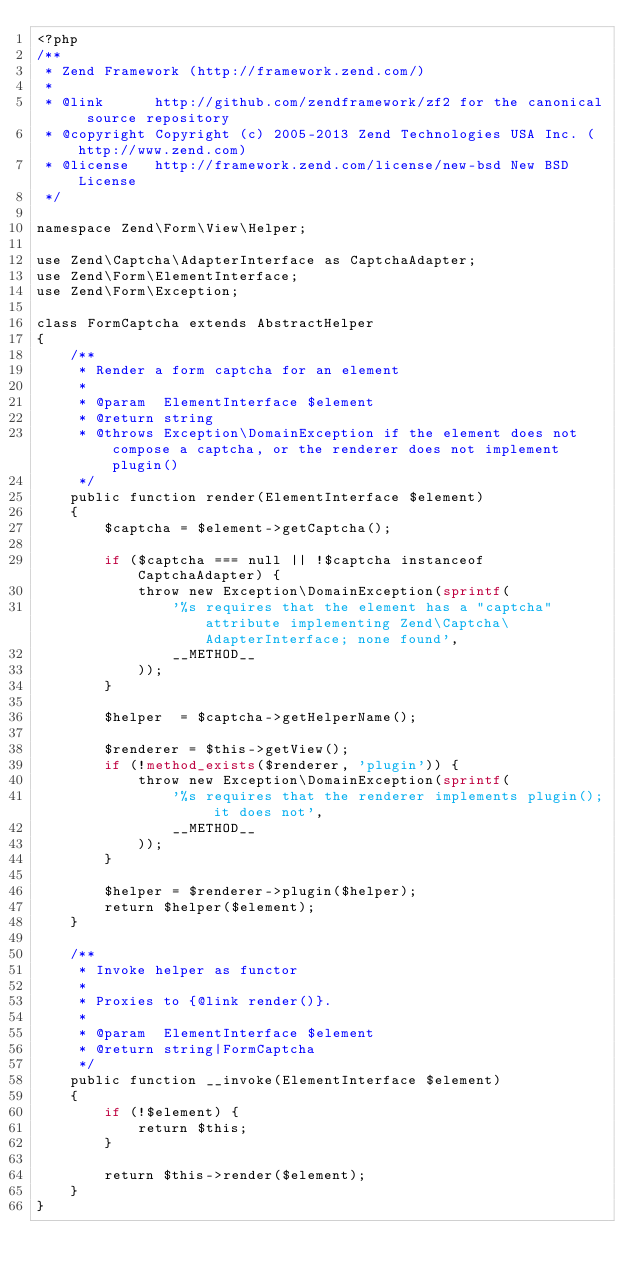<code> <loc_0><loc_0><loc_500><loc_500><_PHP_><?php
/**
 * Zend Framework (http://framework.zend.com/)
 *
 * @link      http://github.com/zendframework/zf2 for the canonical source repository
 * @copyright Copyright (c) 2005-2013 Zend Technologies USA Inc. (http://www.zend.com)
 * @license   http://framework.zend.com/license/new-bsd New BSD License
 */

namespace Zend\Form\View\Helper;

use Zend\Captcha\AdapterInterface as CaptchaAdapter;
use Zend\Form\ElementInterface;
use Zend\Form\Exception;

class FormCaptcha extends AbstractHelper
{
    /**
     * Render a form captcha for an element
     *
     * @param  ElementInterface $element
     * @return string
     * @throws Exception\DomainException if the element does not compose a captcha, or the renderer does not implement plugin()
     */
    public function render(ElementInterface $element)
    {
        $captcha = $element->getCaptcha();

        if ($captcha === null || !$captcha instanceof CaptchaAdapter) {
            throw new Exception\DomainException(sprintf(
                '%s requires that the element has a "captcha" attribute implementing Zend\Captcha\AdapterInterface; none found',
                __METHOD__
            ));
        }

        $helper  = $captcha->getHelperName();

        $renderer = $this->getView();
        if (!method_exists($renderer, 'plugin')) {
            throw new Exception\DomainException(sprintf(
                '%s requires that the renderer implements plugin(); it does not',
                __METHOD__
            ));
        }

        $helper = $renderer->plugin($helper);
        return $helper($element);
    }

    /**
     * Invoke helper as functor
     *
     * Proxies to {@link render()}.
     *
     * @param  ElementInterface $element
     * @return string|FormCaptcha
     */
    public function __invoke(ElementInterface $element)
    {
        if (!$element) {
            return $this;
        }

        return $this->render($element);
    }
}
</code> 